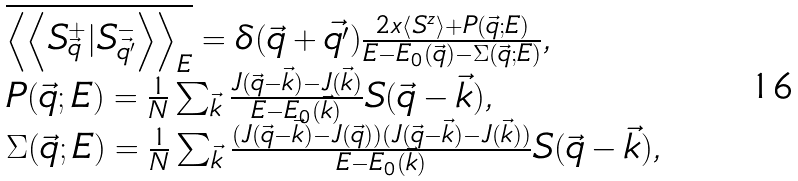Convert formula to latex. <formula><loc_0><loc_0><loc_500><loc_500>\begin{array} { l } \overline { \left \langle \left \langle S _ { \vec { q } } ^ { + } | S _ { \vec { q ^ { \prime } } } ^ { - } \right \rangle \right \rangle _ { E } } = \delta ( \vec { q } + \vec { q ^ { \prime } } ) \frac { 2 x \left \langle S ^ { z } \right \rangle + P ( \vec { q } ; E ) } { E - E _ { 0 } ( \vec { q } ) - \Sigma ( \vec { q } ; E ) } , \\ P ( \vec { q } ; E ) = \frac { 1 } { N } \sum _ { \vec { k } } \frac { J ( \vec { q } - \vec { k } ) - J ( \vec { k } ) } { E - E _ { 0 } ( \vec { k } ) } S ( \vec { q } - \vec { k } ) , \\ \Sigma ( \vec { q } ; E ) = \frac { 1 } { N } \sum _ { \vec { k } } \frac { ( J ( \vec { q } - \vec { k } ) - J ( \vec { q } ) ) ( J ( \vec { q } - \vec { k } ) - J ( \vec { k } ) ) } { E - E _ { 0 } ( \vec { k } ) } S ( \vec { q } - \vec { k } ) , \end{array}</formula> 